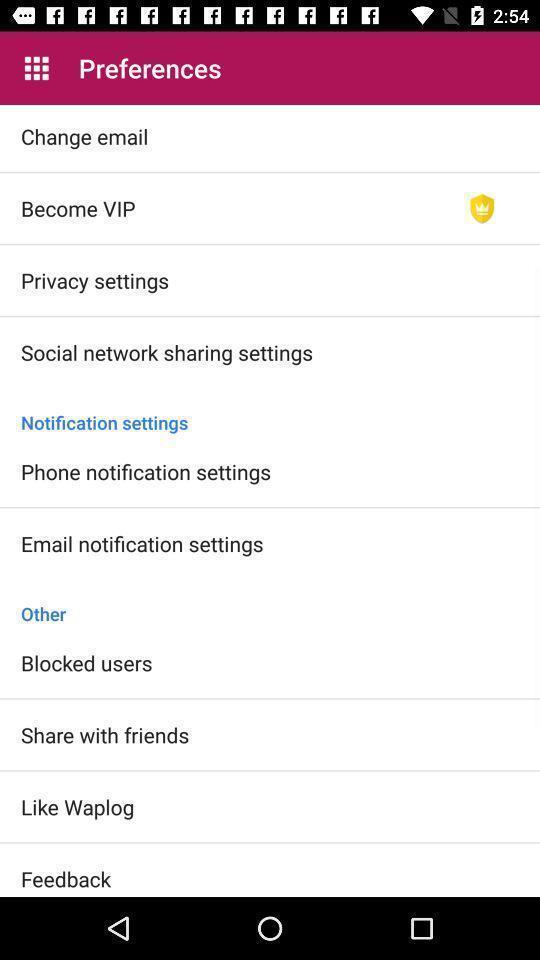Provide a description of this screenshot. Settings page displayed of an dating application. 